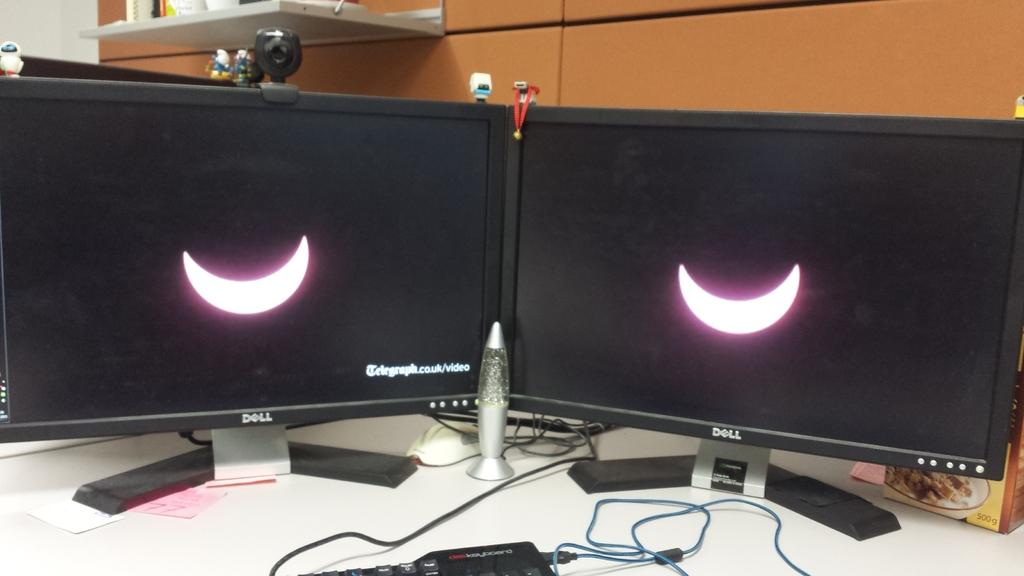<image>
Present a compact description of the photo's key features. Two Dell monitors show either a crescent moon or a solar eclipse. 